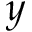<formula> <loc_0><loc_0><loc_500><loc_500>y</formula> 